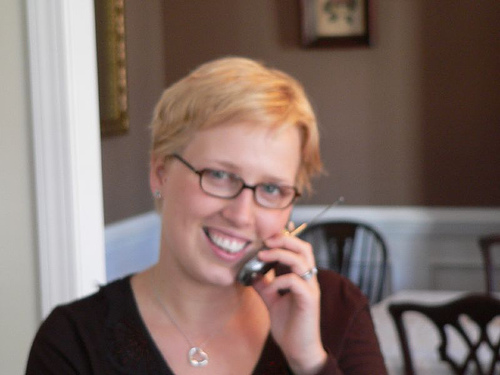<image>What gage is this woman's earring? It's ambiguous to tell the gauge of this woman's earring. What gage is this woman's earring? I am not sure what gage this woman's earring is. 